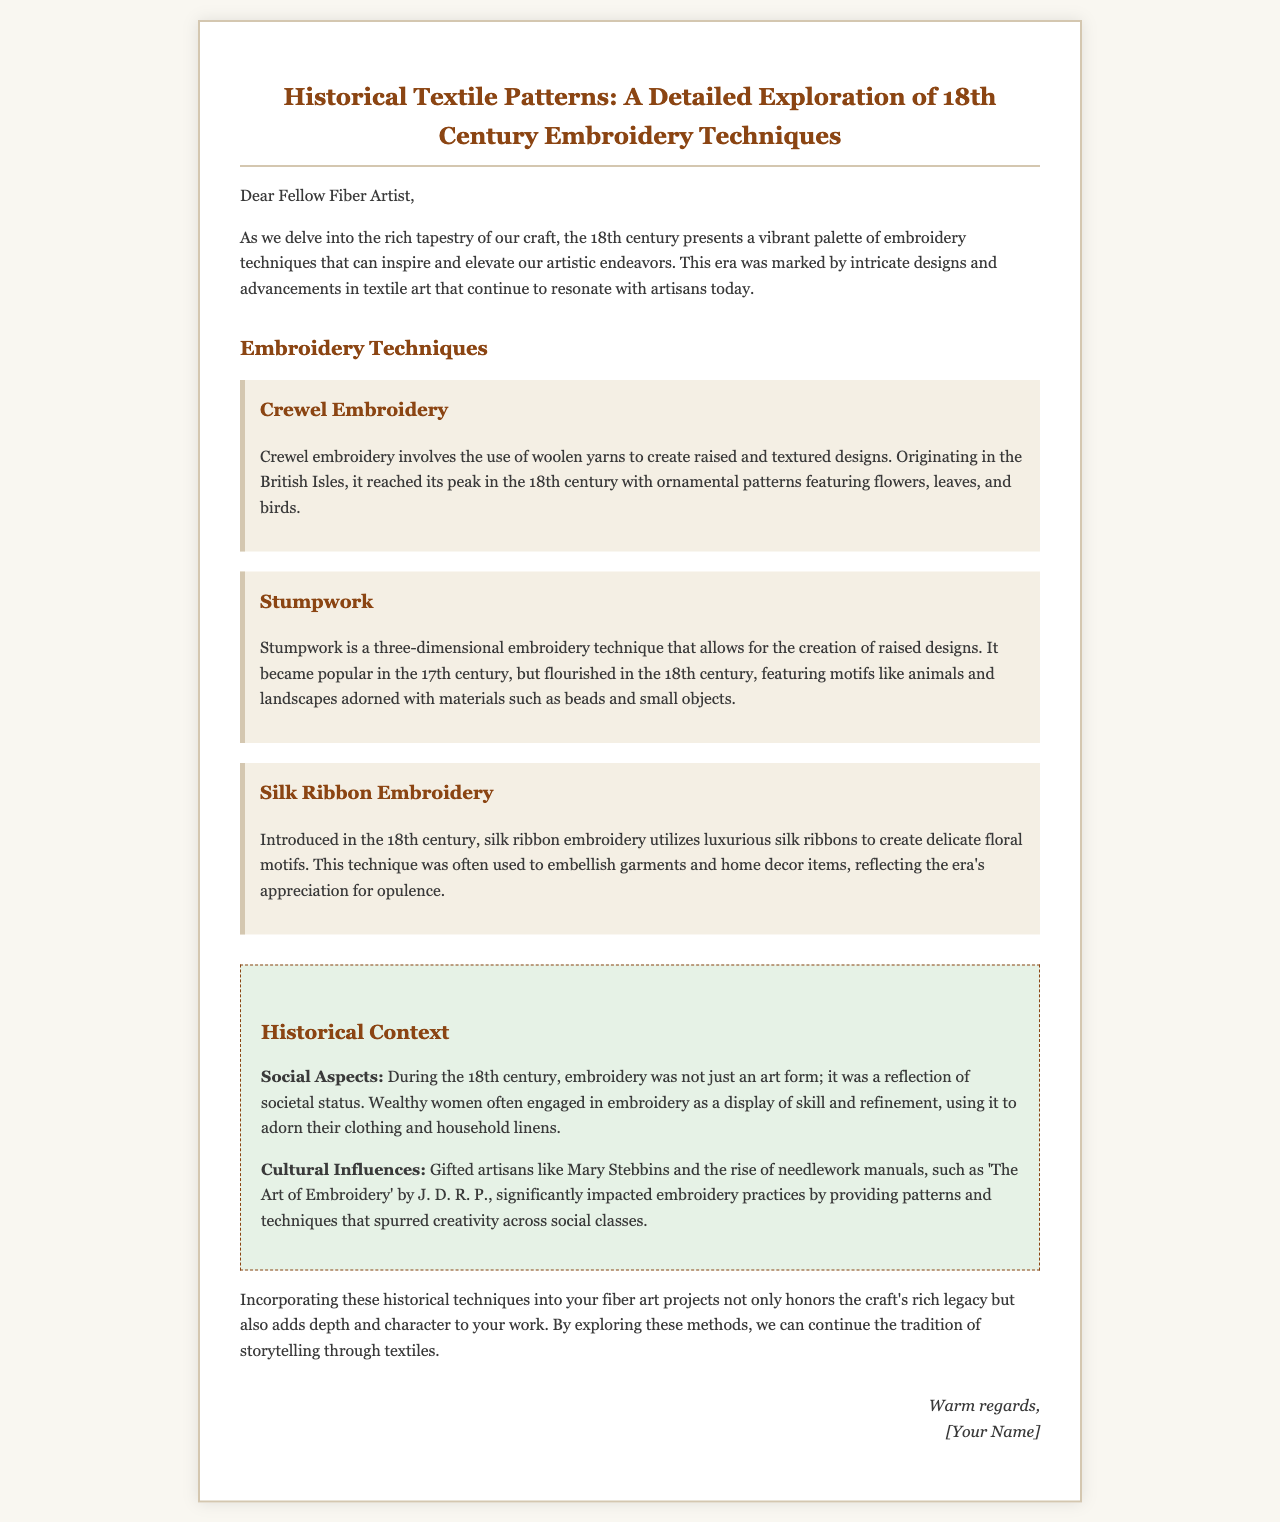What are the three embroidery techniques mentioned? The letter lists three techniques: Crewel Embroidery, Stumpwork, and Silk Ribbon Embroidery.
Answer: Crewel Embroidery, Stumpwork, Silk Ribbon Embroidery What material is used in Crewel Embroidery? The document states that Crewel Embroidery involves the use of woolen yarns.
Answer: Woolen yarns Who is identified as a gifted artisan influencing embroidery practices? The letter mentions Mary Stebbins as a significant figure in the embroidery field during the 18th century.
Answer: Mary Stebbins During which century did Silk Ribbon Embroidery emerge? The document specifies that Silk Ribbon Embroidery was introduced in the 18th century.
Answer: 18th century What is one social aspect of 18th-century embroidery mentioned? The letter notes that embroidery was a reflection of societal status during this period.
Answer: Societal status What is a significant cultural influence on 18th-century embroidery according to the letter? The document states that the rise of needlework manuals, like 'The Art of Embroidery', significantly impacted embroidery practices.
Answer: Needlework manuals What type of document is this content formatted as? The content resembles a letter addressed to a fellow fiber artist, encouraging exploration of embroidery techniques.
Answer: Letter What purpose does the author encourage readers to achieve by using historical techniques? The author suggests incorporating historical techniques to honor the craft's legacy and add depth to one's work.
Answer: Honor the craft's legacy 